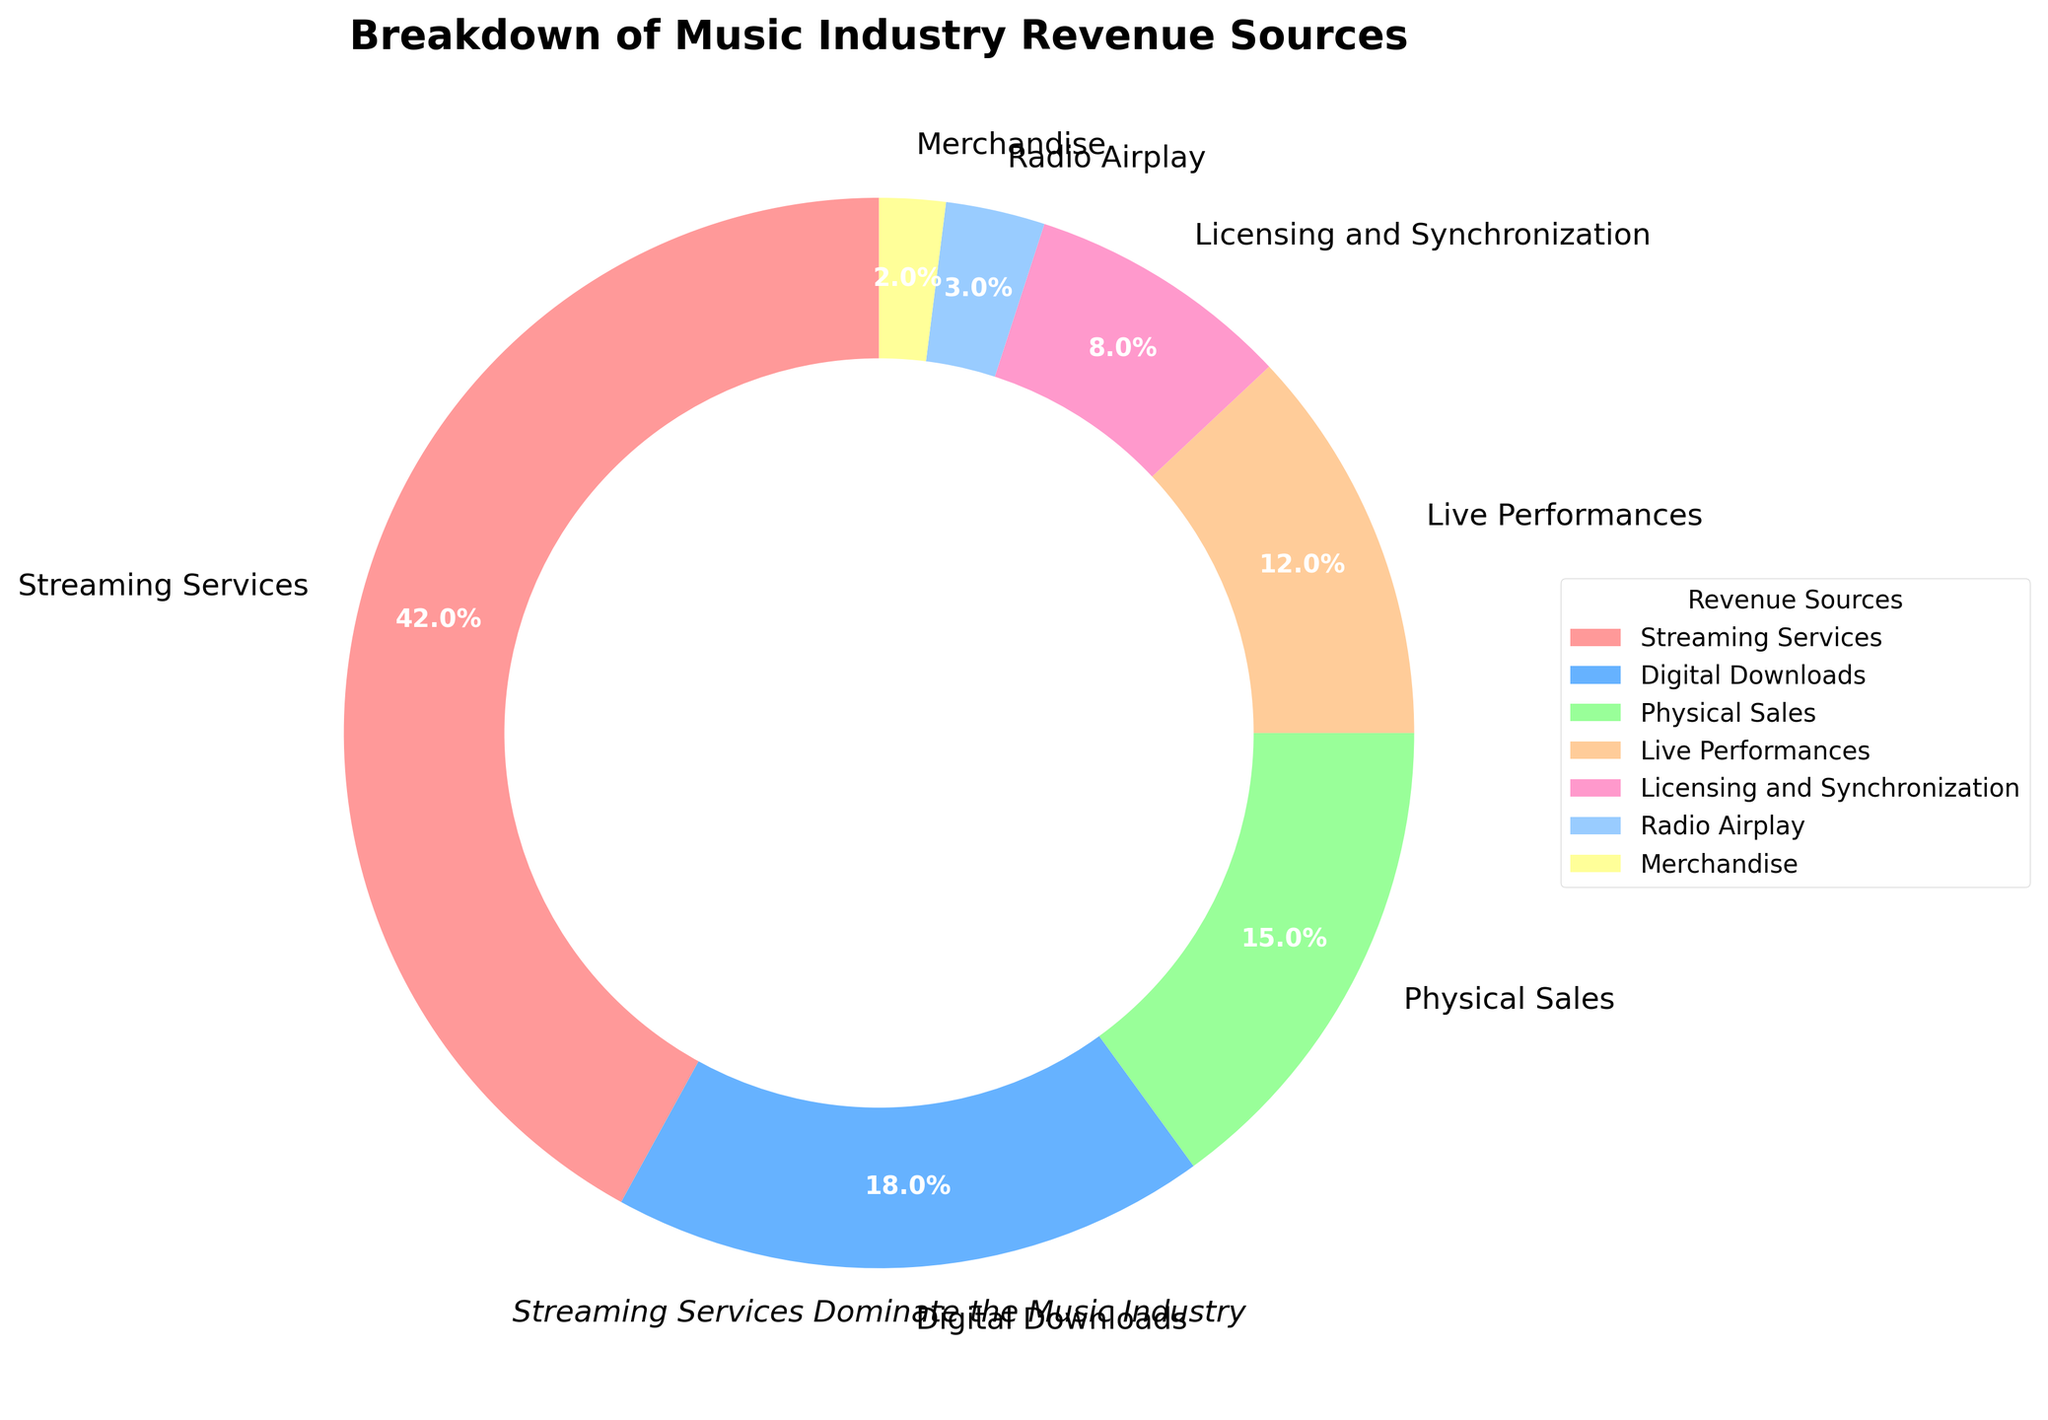What is the largest source of revenue for the music industry? The figure shows that the segment labeled "Streaming Services" has the largest percentage at 42%.
Answer: Streaming Services Which two revenue sources combined make up more than 50% of the total revenue? Adding the percentages of the largest sources, Streaming Services (42%) and Digital Downloads (18%), results in 60%, which is more than half the total revenue.
Answer: Streaming Services and Digital Downloads How much more percentage do Streaming Services contribute compared to Physical Sales? The percentage for Streaming Services is 42%, and for Physical Sales, it is 15%. The difference is 42% - 15% = 27%.
Answer: 27% If you add the percentages of Live Performances and Licensing & Synchronization, does it exceed the contribution of Digital Downloads? Live Performances contribute 12%, and Licensing & Synchronization contribute 8%. Combined, they add up to 20%, which is more than Digital Downloads' 18%.
Answer: Yes Which revenue source contributes the least? The figure indicates that Merchandise is the smallest segment with a contribution of 2%.
Answer: Merchandise What percentage of the revenue comes from sources other than Streaming Services? Subtracting the percentage of Streaming Services (42%) from 100% gives 58%.
Answer: 58% How many percentage points separate Licensing & Synchronization from Radio Airplay? Licensing & Synchronization contributes 8%, and Radio Airplay contributes 3%. The difference is 8% - 3% = 5%.
Answer: 5% If the revenue from Digital Downloads doubled, what percentage would it represent in total? Doubling the percentage of Digital Downloads (18%) gives 36%. Adding it to the total, we would have 36% + 42% (Streaming Services) + 15% (Physical Sales) + 12% (Live Performances) + 8% (Licensing & Synchronization) + 3% (Radio Airplay) + 2% (Merchandise) = 118%. The new percentage for Digital Downloads would be 36/118 * 100% ≈ 30.5%.
Answer: ~30.5% Which sector contributes more to the revenue, Live Performances or Physical Sales? Comparing the percentages, Physical Sales contribute 15% and Live Performances contribute 12%. Physical Sales exceed Live Performances by 3 percentage points.
Answer: Physical Sales What colors are used for the largest and smallest revenue segments? The pie chart uses red for the largest segment, Streaming Services, and yellow for the smallest segment, Merchandise.
Answer: Red and Yellow 